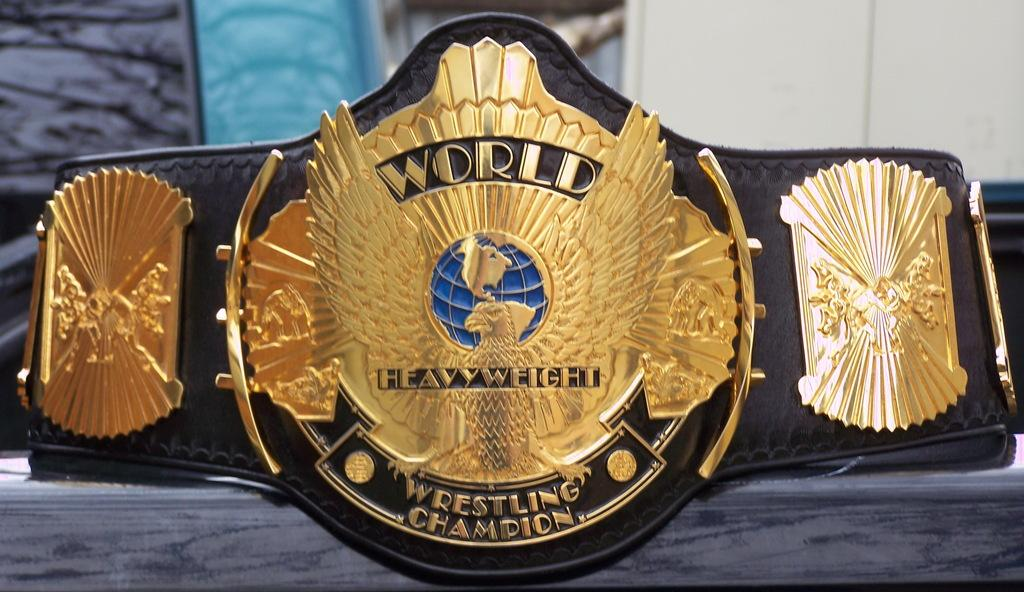What is the main subject of the image? The main subject of the image is a world heavyweight wrestling championship belt. Where is the belt located in the image? The belt is present on a table. What type of pipe is visible in the image? There is no pipe present in the image. What boundary is depicted in the image? There is no boundary depicted in the image; it features a world heavyweight wrestling championship belt on a table. 